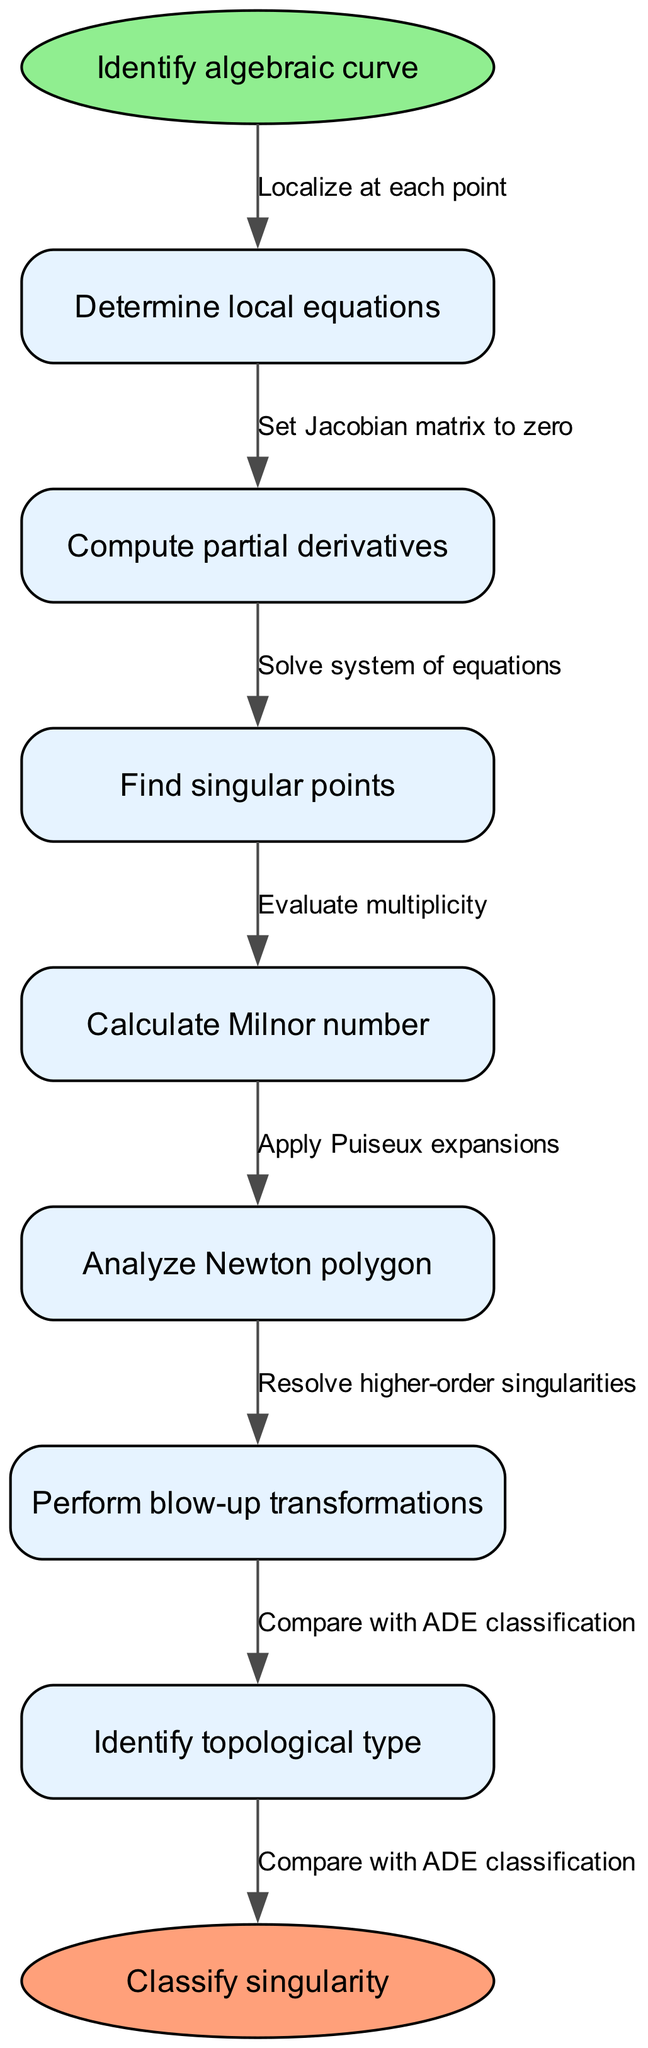What is the first step in the classification process? The flow chart indicates that the first step is to "Identify algebraic curve." This is the entry point before any other processes take place.
Answer: Identify algebraic curve How many nodes are present in the flow chart? The flow chart lists 7 nodes that detail the steps in the classification process. Each step corresponds to a specific action taken in the process.
Answer: 7 What does the last node signify? The last node denotes the outcome of the classification process, signified by "Classify singularity," indicating the final result of the preceding steps.
Answer: Classify singularity What step follows the calculation of the Milnor number? After calculating the Milnor number, the next step is to "Analyze Newton polygon," which continues the flow toward classification.
Answer: Analyze Newton polygon What edge connects the step for finding singular points to calculating the Milnor number? The connection is made through the edge labeled "Solve system of equations," which reflects the action taken after identifying singular points.
Answer: Solve system of equations Which node involves performing transformations? The node indicating the performance of transformations is "Perform blow-up transformations." This action is crucial for resolving singularities in the classification process.
Answer: Perform blow-up transformations Which two steps are connected by "Apply Puiseux expansions"? The steps connected by this edge are "Analyze Newton polygon" and "Resolve higher-order singularities," indicating the relationship between analyzing the Newton polygon and further resolving singularities through expansions.
Answer: Analyze Newton polygon and Resolve higher-order singularities How is the topological type identified in the process? The topological type is identified in the step labeled "Identify topological type," which is the sixth node in the sequence before arriving at the classification outcome.
Answer: Identify topological type What is the significance of the Jacobian matrix in this flow chart? The Jacobian matrix is significant as it is used in the step "Set Jacobian matrix to zero," which is fundamental for finding singular points in the algebraic curves.
Answer: Set Jacobian matrix to zero 